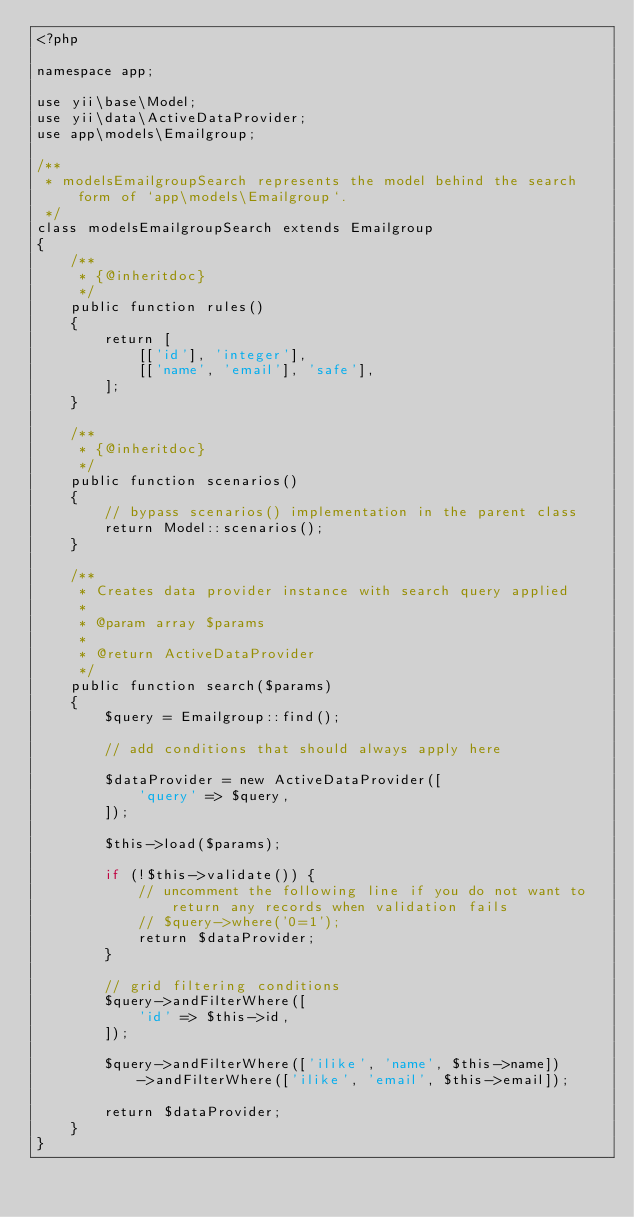Convert code to text. <code><loc_0><loc_0><loc_500><loc_500><_PHP_><?php

namespace app;

use yii\base\Model;
use yii\data\ActiveDataProvider;
use app\models\Emailgroup;

/**
 * modelsEmailgroupSearch represents the model behind the search form of `app\models\Emailgroup`.
 */
class modelsEmailgroupSearch extends Emailgroup
{
    /**
     * {@inheritdoc}
     */
    public function rules()
    {
        return [
            [['id'], 'integer'],
            [['name', 'email'], 'safe'],
        ];
    }

    /**
     * {@inheritdoc}
     */
    public function scenarios()
    {
        // bypass scenarios() implementation in the parent class
        return Model::scenarios();
    }

    /**
     * Creates data provider instance with search query applied
     *
     * @param array $params
     *
     * @return ActiveDataProvider
     */
    public function search($params)
    {
        $query = Emailgroup::find();

        // add conditions that should always apply here

        $dataProvider = new ActiveDataProvider([
            'query' => $query,
        ]);

        $this->load($params);

        if (!$this->validate()) {
            // uncomment the following line if you do not want to return any records when validation fails
            // $query->where('0=1');
            return $dataProvider;
        }

        // grid filtering conditions
        $query->andFilterWhere([
            'id' => $this->id,
        ]);

        $query->andFilterWhere(['ilike', 'name', $this->name])
            ->andFilterWhere(['ilike', 'email', $this->email]);

        return $dataProvider;
    }
}
</code> 